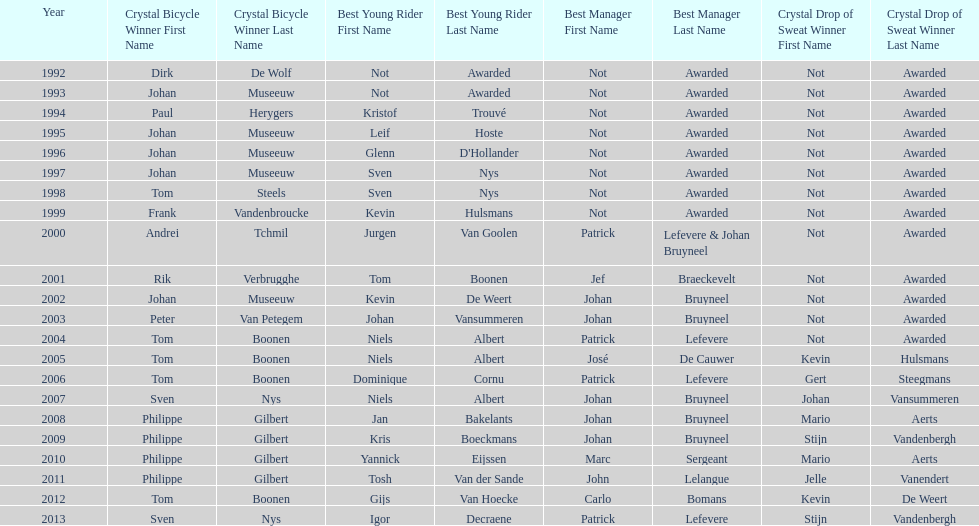Who won the most consecutive crystal bicycles? Philippe Gilbert. 